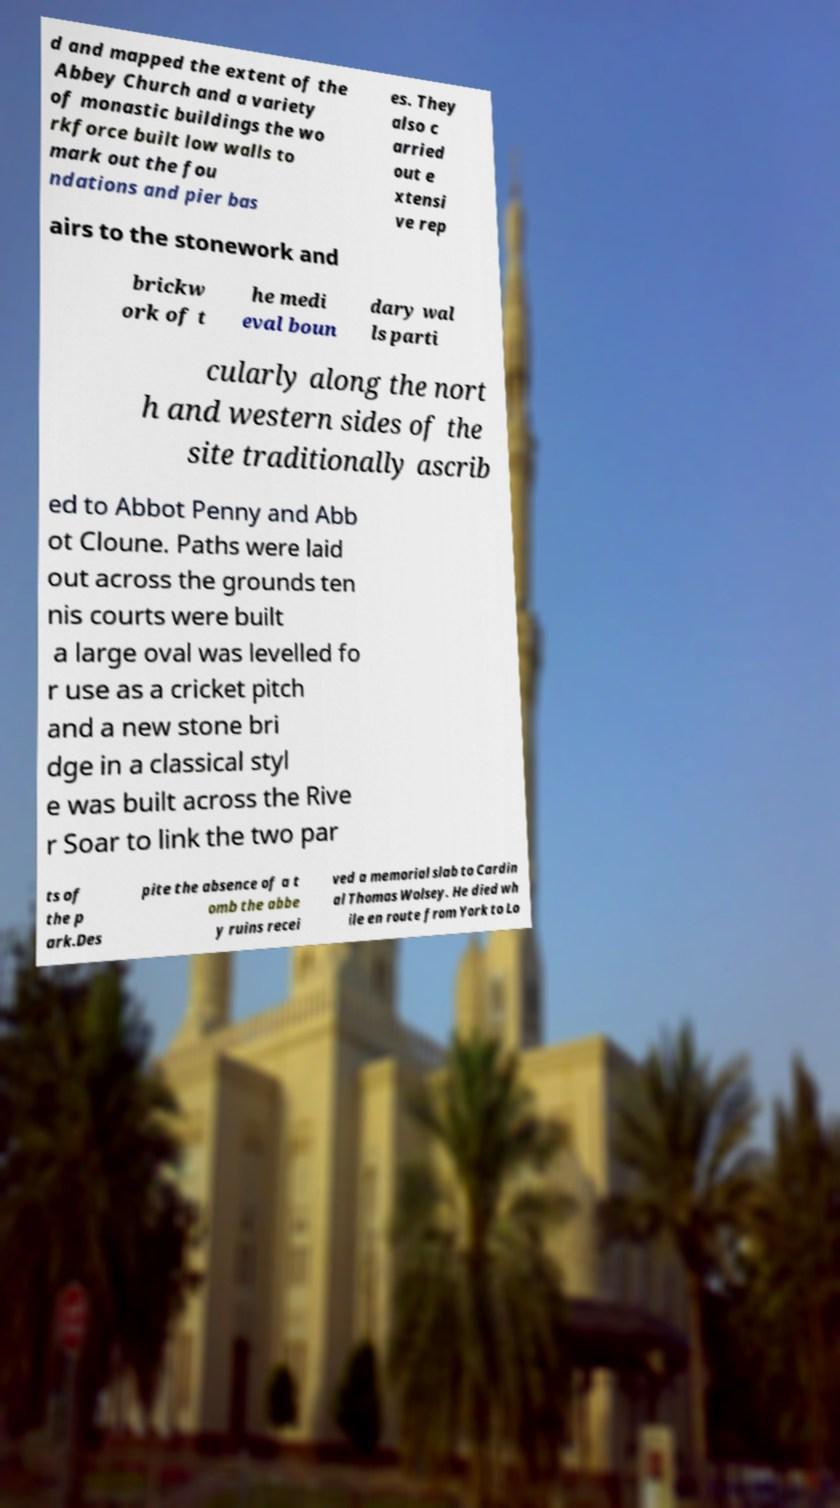Please read and relay the text visible in this image. What does it say? d and mapped the extent of the Abbey Church and a variety of monastic buildings the wo rkforce built low walls to mark out the fou ndations and pier bas es. They also c arried out e xtensi ve rep airs to the stonework and brickw ork of t he medi eval boun dary wal ls parti cularly along the nort h and western sides of the site traditionally ascrib ed to Abbot Penny and Abb ot Cloune. Paths were laid out across the grounds ten nis courts were built a large oval was levelled fo r use as a cricket pitch and a new stone bri dge in a classical styl e was built across the Rive r Soar to link the two par ts of the p ark.Des pite the absence of a t omb the abbe y ruins recei ved a memorial slab to Cardin al Thomas Wolsey. He died wh ile en route from York to Lo 